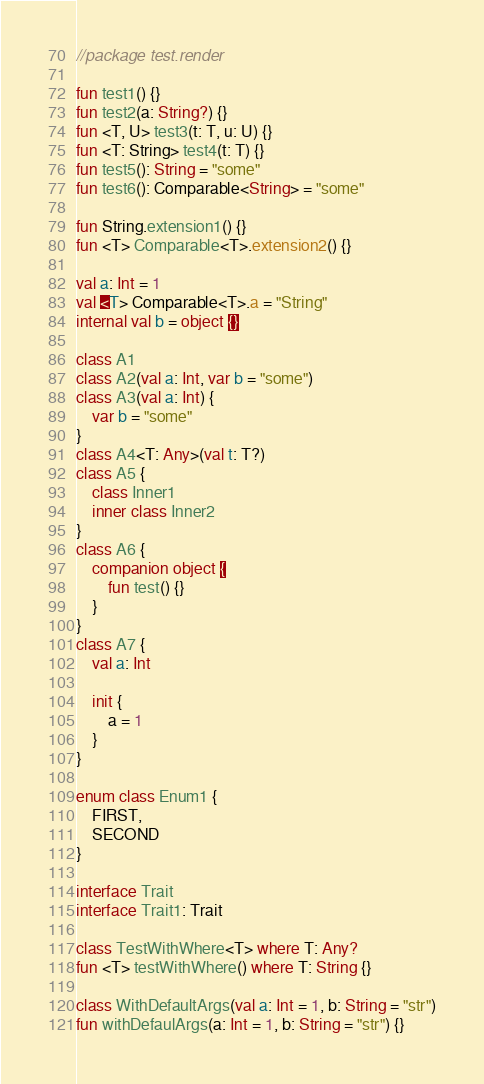<code> <loc_0><loc_0><loc_500><loc_500><_Kotlin_>//package test.render

fun test1() {}
fun test2(a: String?) {}
fun <T, U> test3(t: T, u: U) {}
fun <T: String> test4(t: T) {}
fun test5(): String = "some"
fun test6(): Comparable<String> = "some"

fun String.extension1() {}
fun <T> Comparable<T>.extension2() {}

val a: Int = 1
val <T> Comparable<T>.a = "String"
internal val b = object {}

class A1
class A2(val a: Int, var b = "some")
class A3(val a: Int) {
    var b = "some"
}
class A4<T: Any>(val t: T?)
class A5 {
    class Inner1
    inner class Inner2
}
class A6 {
    companion object {
        fun test() {}
    }
}
class A7 {
    val a: Int

    init {
        a = 1
    }
}

enum class Enum1 {
    FIRST,
    SECOND
}

interface Trait
interface Trait1: Trait

class TestWithWhere<T> where T: Any?
fun <T> testWithWhere() where T: String {}

class WithDefaultArgs(val a: Int = 1, b: String = "str")
fun withDefaulArgs(a: Int = 1, b: String = "str") {}


</code> 